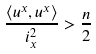<formula> <loc_0><loc_0><loc_500><loc_500>\frac { \langle u ^ { x } , u ^ { x } \rangle } { i _ { x } ^ { 2 } } > \frac { n } { 2 }</formula> 